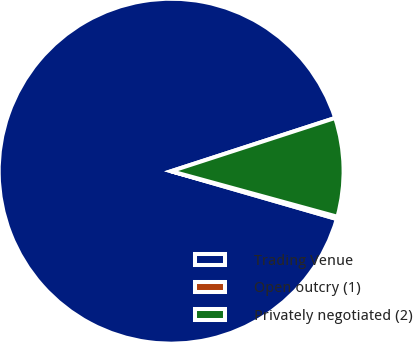Convert chart to OTSL. <chart><loc_0><loc_0><loc_500><loc_500><pie_chart><fcel>Trading Venue<fcel>Open outcry (1)<fcel>Privately negotiated (2)<nl><fcel>90.52%<fcel>0.22%<fcel>9.25%<nl></chart> 